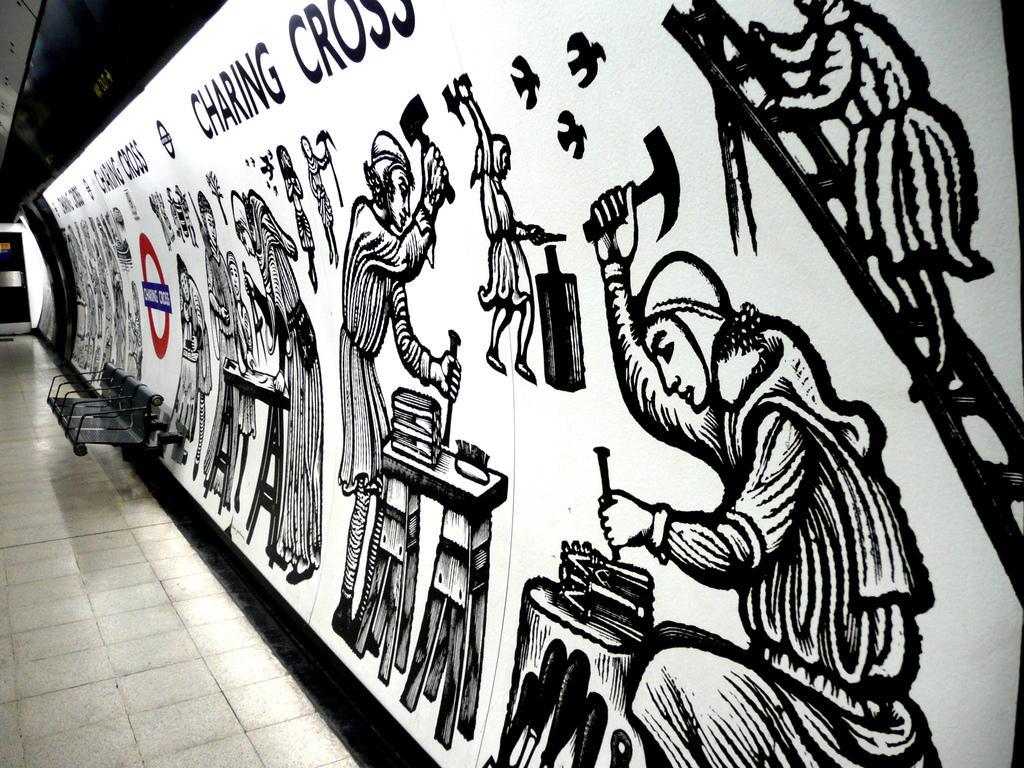Can you describe this image briefly? In this image in front there is a floor. There is a bench. On the right side of the image there is a painting on the wall. 